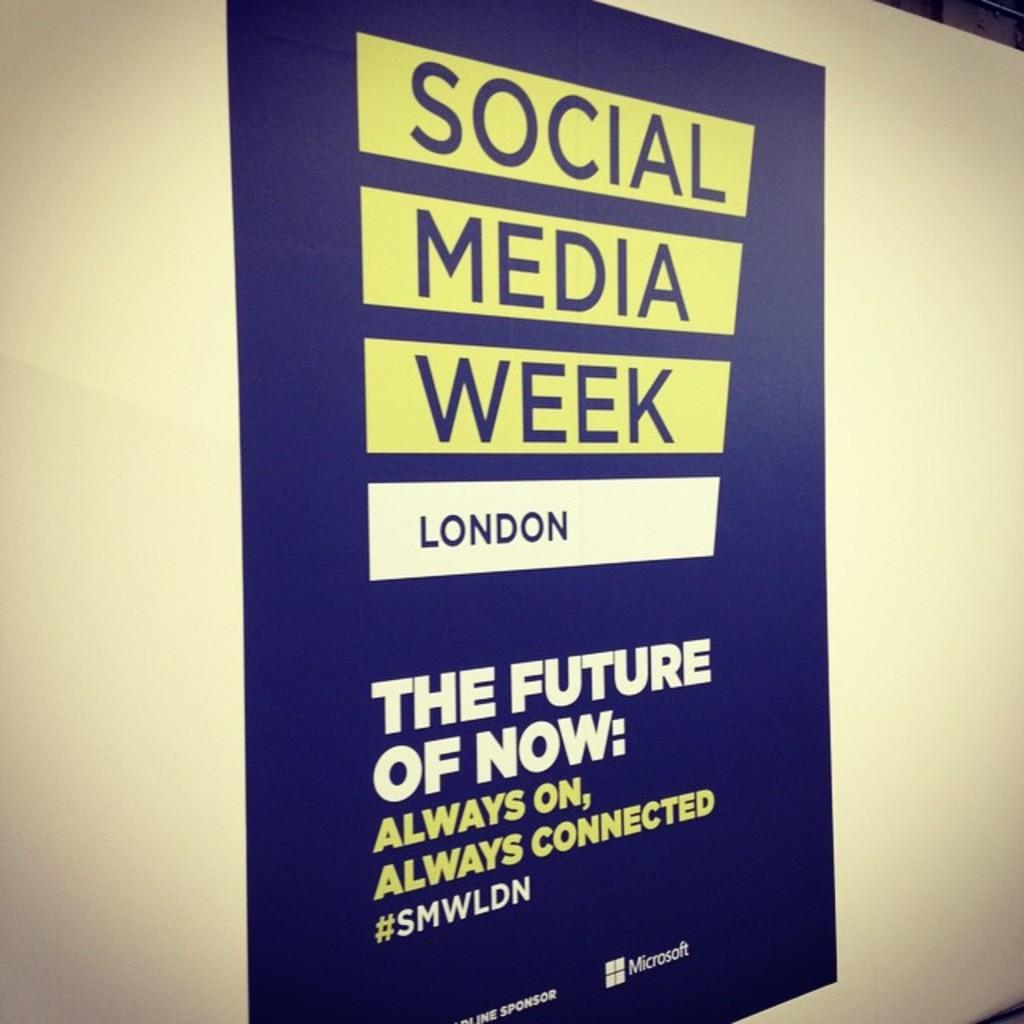<image>
Relay a brief, clear account of the picture shown. A poster declares that it's Social Media Week in London and the subject is THE FUTURE OF NOW. 